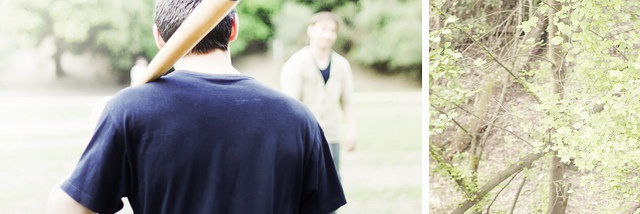Describe the objects in this image and their specific colors. I can see people in ivory, black, navy, blue, and white tones, people in ivory, white, beige, and darkgray tones, and baseball bat in ivory and tan tones in this image. 